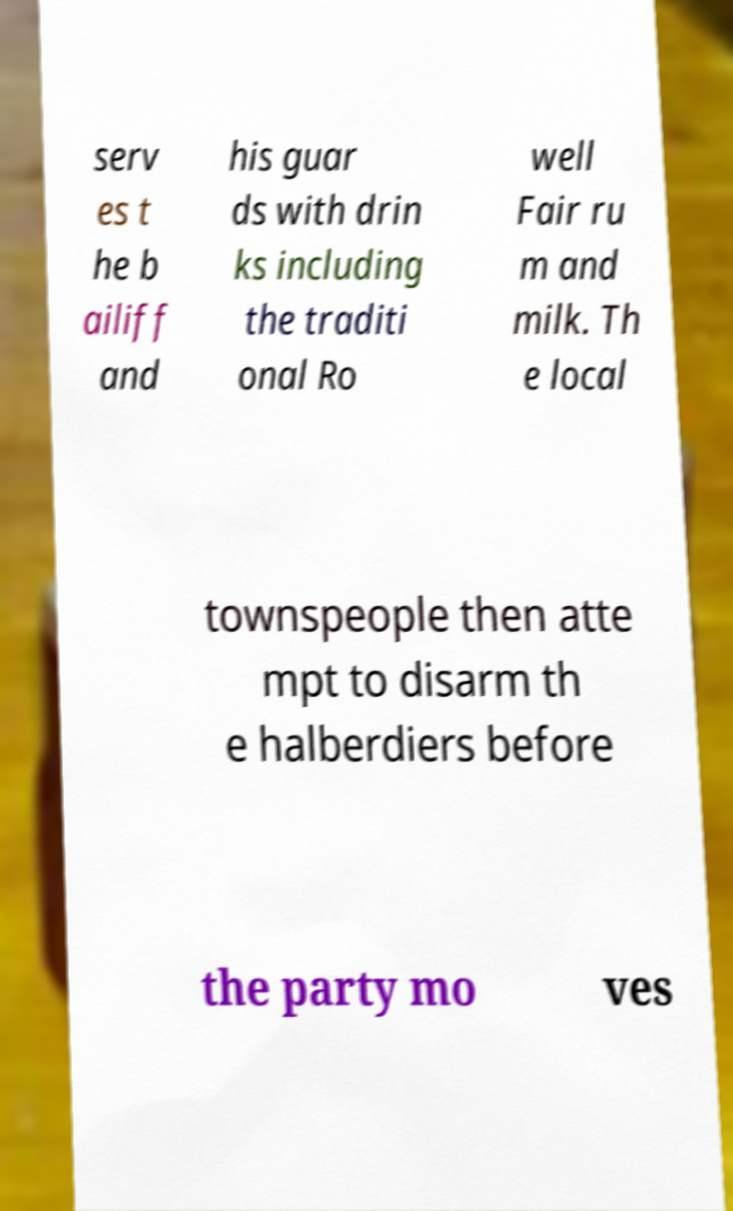Can you accurately transcribe the text from the provided image for me? serv es t he b ailiff and his guar ds with drin ks including the traditi onal Ro well Fair ru m and milk. Th e local townspeople then atte mpt to disarm th e halberdiers before the party mo ves 